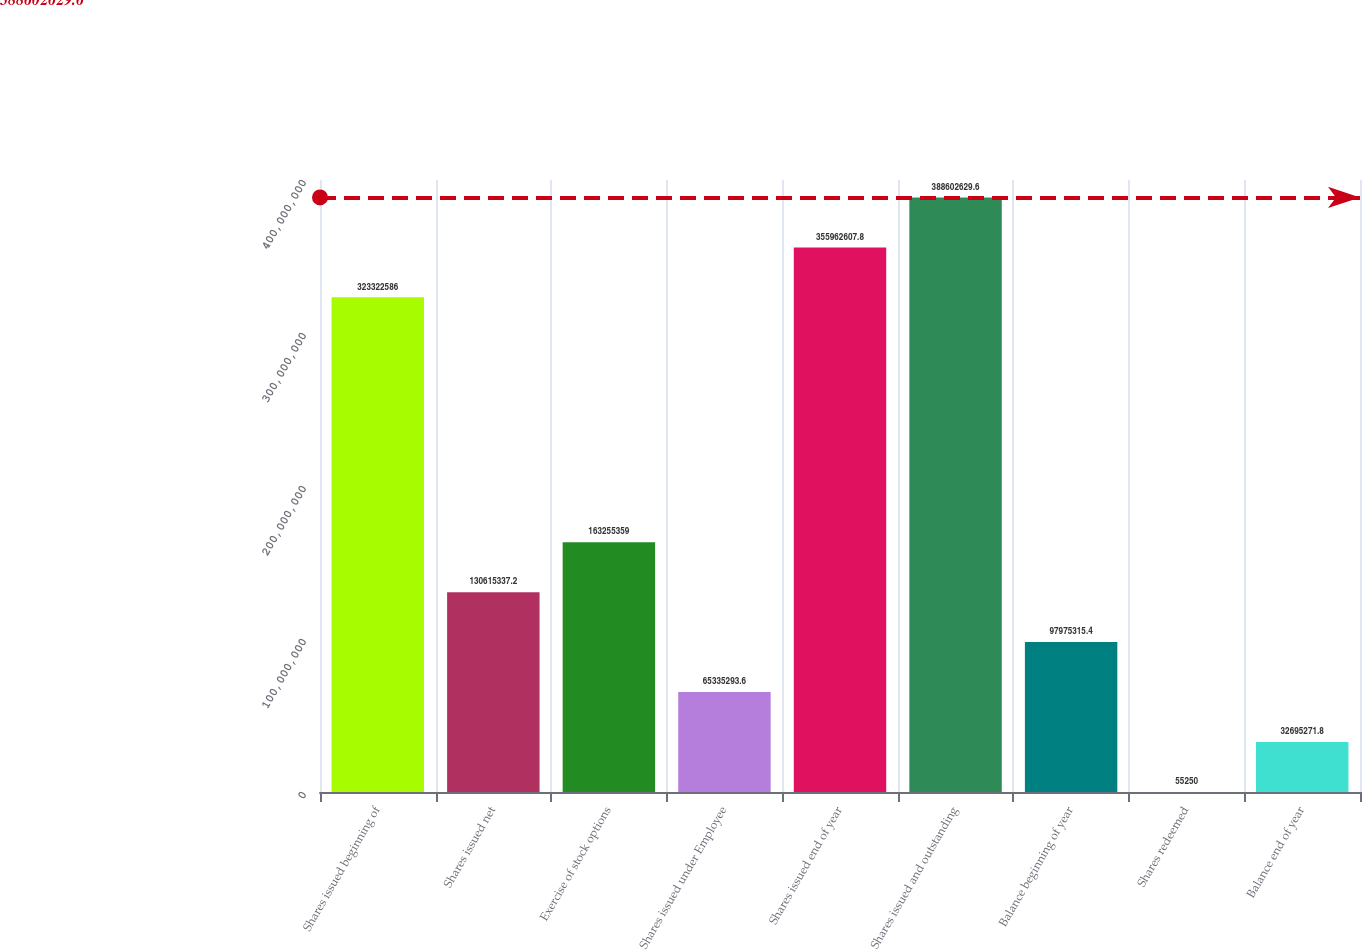Convert chart. <chart><loc_0><loc_0><loc_500><loc_500><bar_chart><fcel>Shares issued beginning of<fcel>Shares issued net<fcel>Exercise of stock options<fcel>Shares issued under Employee<fcel>Shares issued end of year<fcel>Shares issued and outstanding<fcel>Balance beginning of year<fcel>Shares redeemed<fcel>Balance end of year<nl><fcel>3.23323e+08<fcel>1.30615e+08<fcel>1.63255e+08<fcel>6.53353e+07<fcel>3.55963e+08<fcel>3.88603e+08<fcel>9.79753e+07<fcel>55250<fcel>3.26953e+07<nl></chart> 